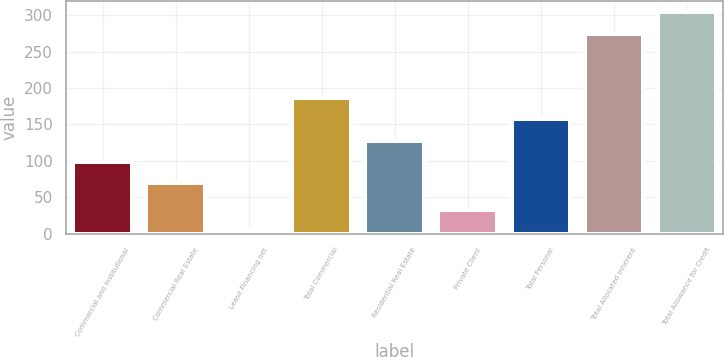<chart> <loc_0><loc_0><loc_500><loc_500><bar_chart><fcel>Commercial and Institutional<fcel>Commercial Real Estate<fcel>Lease Financing net<fcel>Total Commercial<fcel>Residential Real Estate<fcel>Private Client<fcel>Total Personal<fcel>Total Allocated Inherent<fcel>Total Allowance for Credit<nl><fcel>98.63<fcel>69.4<fcel>3.6<fcel>186.32<fcel>127.86<fcel>32.83<fcel>157.09<fcel>274.8<fcel>304.03<nl></chart> 